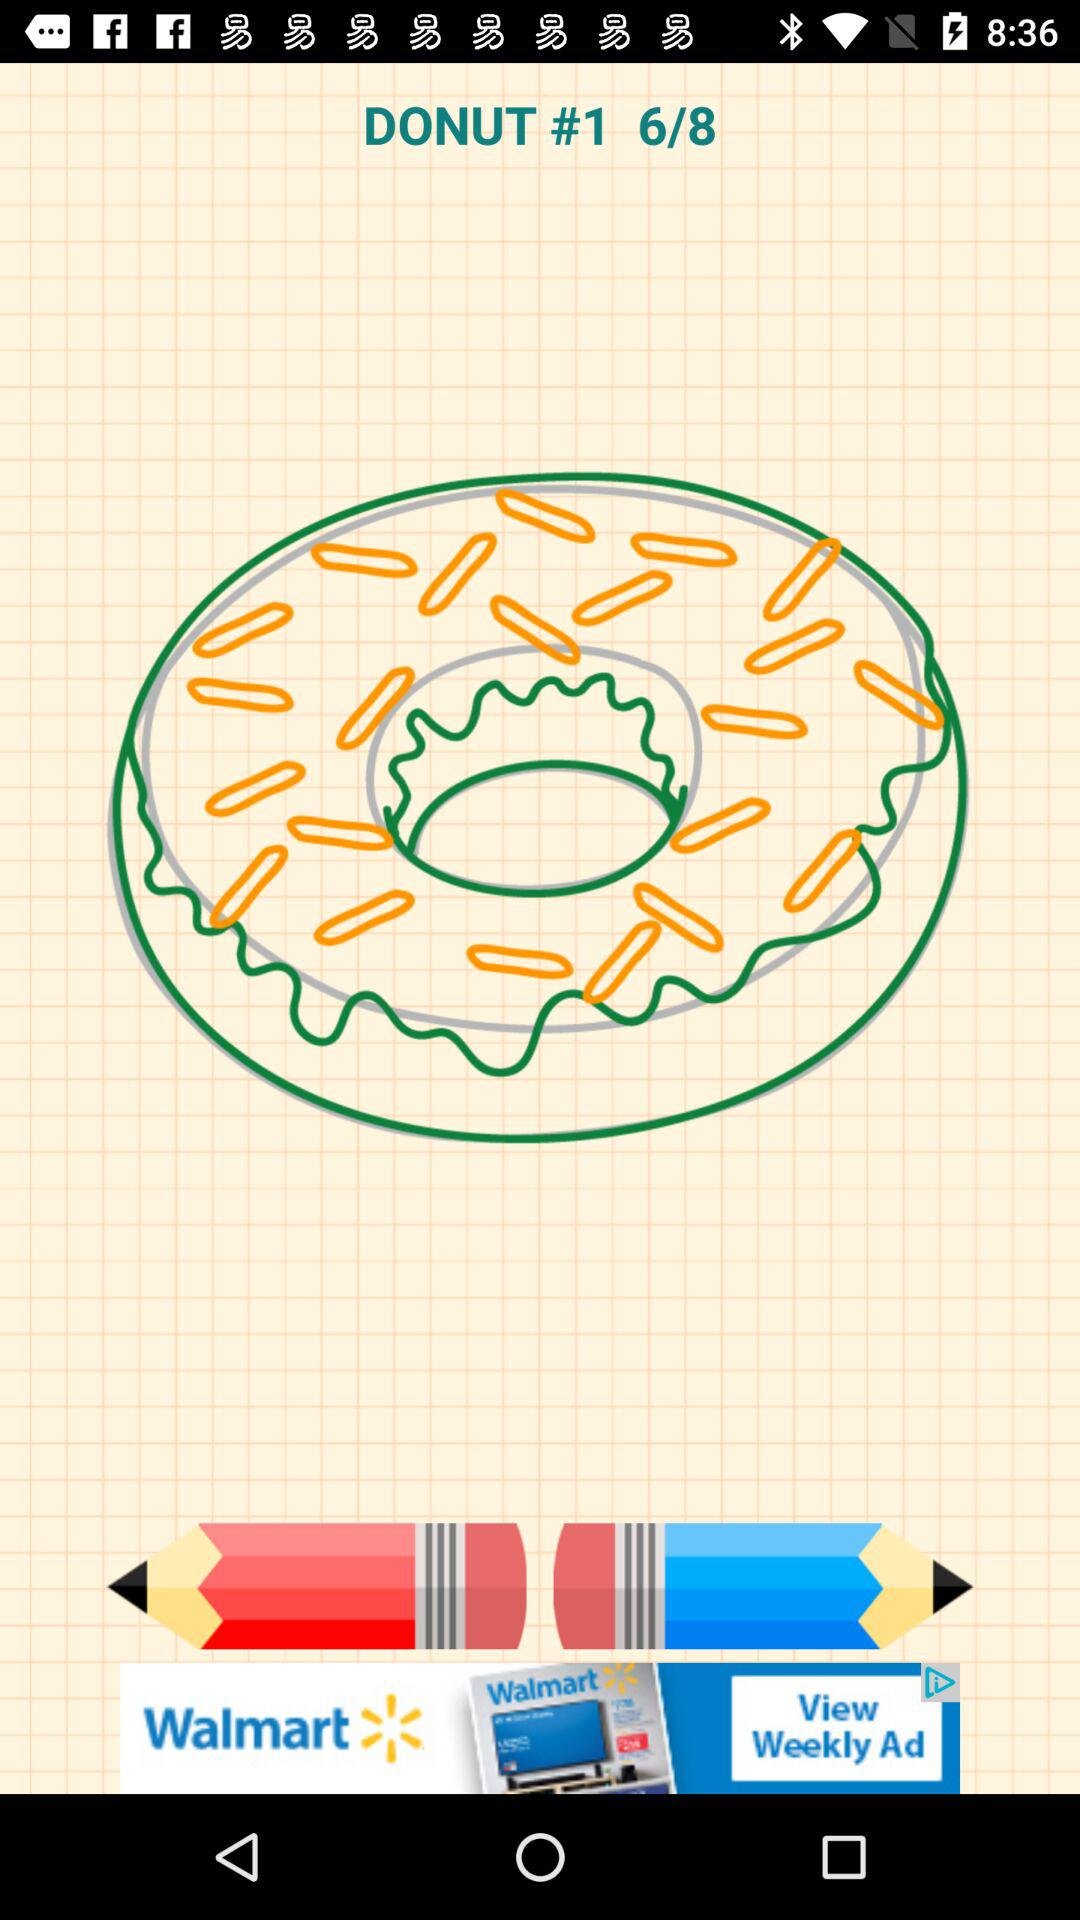What is the title of the image? The title of the image is "DONUT". 